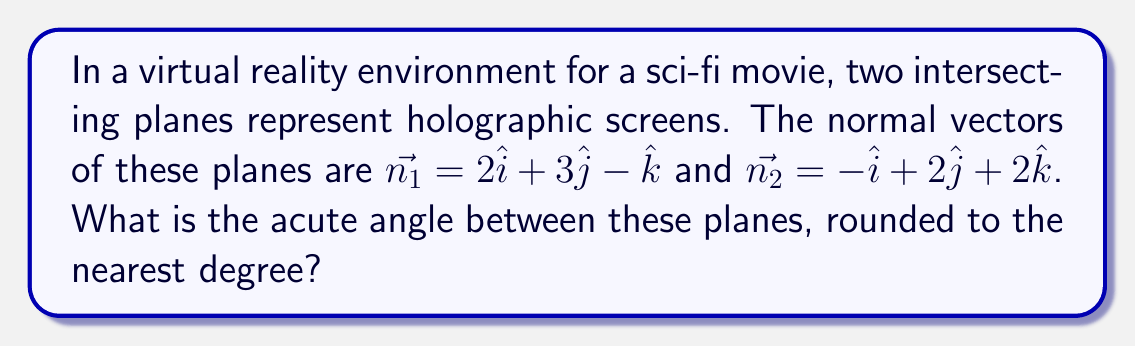Give your solution to this math problem. To find the angle between two intersecting planes, we can use the angle between their normal vectors. The steps are as follows:

1) The formula for the angle $\theta$ between two vectors $\vec{a}$ and $\vec{b}$ is:

   $$\cos \theta = \frac{\vec{a} \cdot \vec{b}}{|\vec{a}||\vec{b}|}$$

2) First, calculate the dot product $\vec{n_1} \cdot \vec{n_2}$:
   $$\vec{n_1} \cdot \vec{n_2} = (2)(-1) + (3)(2) + (-1)(2) = -2 + 6 - 2 = 2$$

3) Calculate the magnitudes of the vectors:
   $$|\vec{n_1}| = \sqrt{2^2 + 3^2 + (-1)^2} = \sqrt{14}$$
   $$|\vec{n_2}| = \sqrt{(-1)^2 + 2^2 + 2^2} = 3$$

4) Substitute into the formula:
   $$\cos \theta = \frac{2}{\sqrt{14} \cdot 3}$$

5) Take the inverse cosine (arccos) of both sides:
   $$\theta = \arccos\left(\frac{2}{\sqrt{14} \cdot 3}\right)$$

6) Calculate and round to the nearest degree:
   $$\theta \approx 78^\circ$$

Note: We take the acute angle, which is less than or equal to 90°.
Answer: 78° 